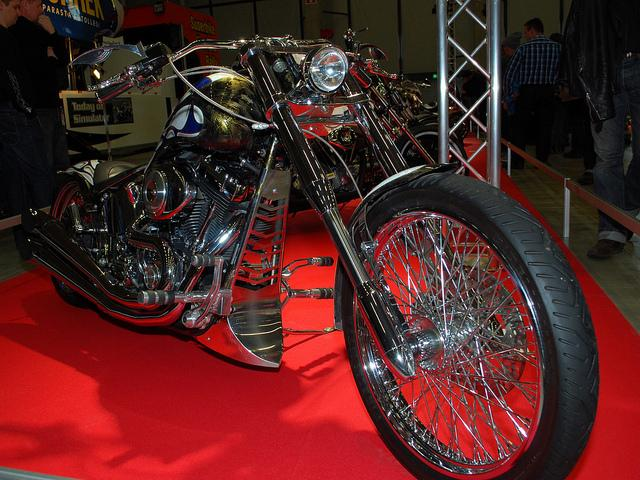Where is this bike located?

Choices:
A) driveway
B) mechanic
C) museum
D) parking lot museum 